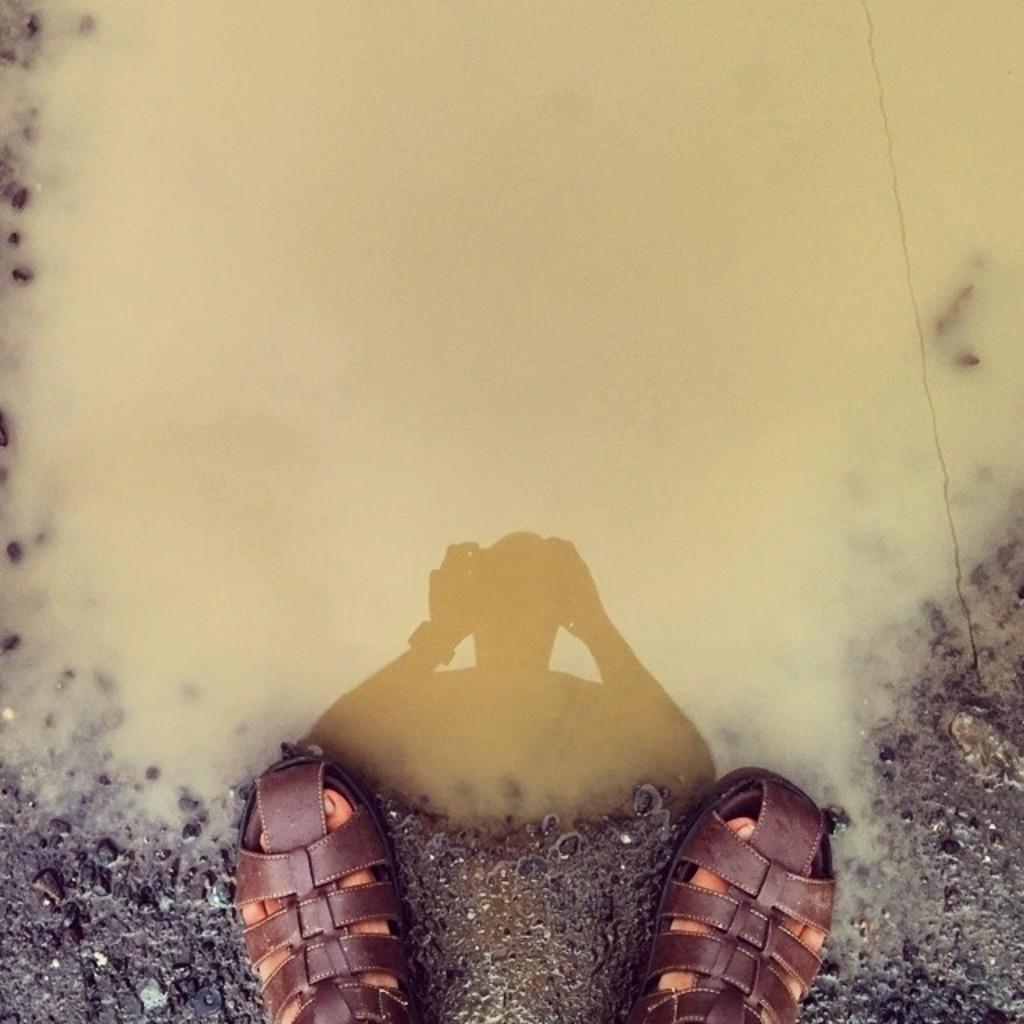What is visible in the image related to a person's feet? There is a person's feet with footwear in the image. What can be seen in the background of the image? There is muddy water in the background of the image. What religion is the person practicing in the image? There is no indication of religion in the image, as it only shows a person's feet with footwear and muddy water in the background. 